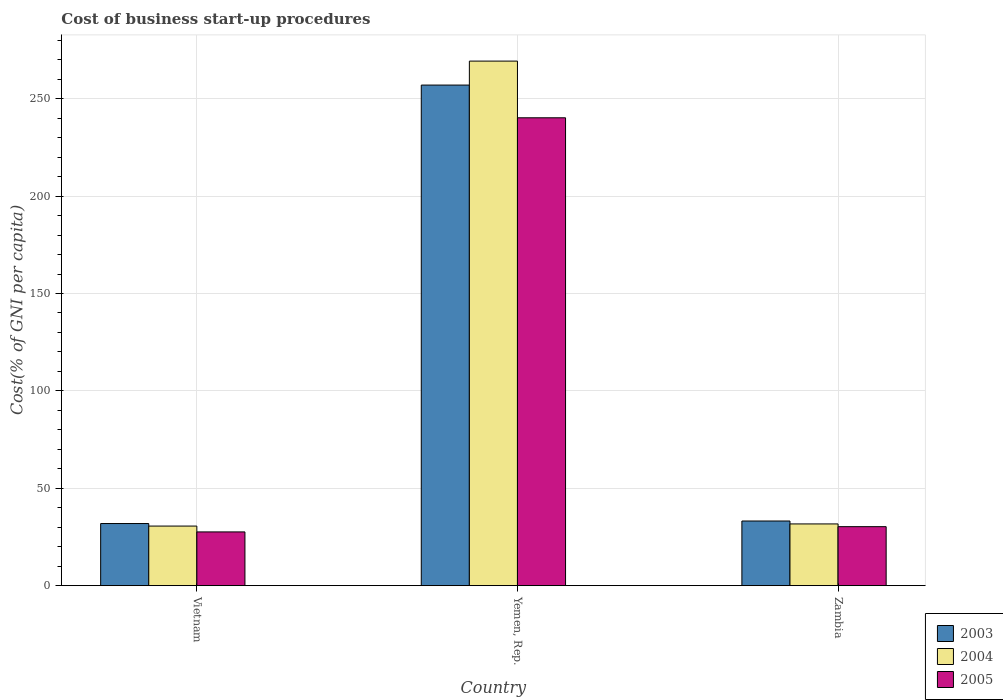How many groups of bars are there?
Give a very brief answer. 3. How many bars are there on the 2nd tick from the right?
Make the answer very short. 3. What is the label of the 2nd group of bars from the left?
Your answer should be compact. Yemen, Rep. What is the cost of business start-up procedures in 2005 in Vietnam?
Provide a short and direct response. 27.6. Across all countries, what is the maximum cost of business start-up procedures in 2005?
Your answer should be very brief. 240.2. Across all countries, what is the minimum cost of business start-up procedures in 2003?
Ensure brevity in your answer.  31.9. In which country was the cost of business start-up procedures in 2003 maximum?
Your response must be concise. Yemen, Rep. In which country was the cost of business start-up procedures in 2005 minimum?
Provide a short and direct response. Vietnam. What is the total cost of business start-up procedures in 2005 in the graph?
Offer a very short reply. 298.1. What is the difference between the cost of business start-up procedures in 2005 in Vietnam and that in Yemen, Rep.?
Give a very brief answer. -212.6. What is the difference between the cost of business start-up procedures in 2003 in Yemen, Rep. and the cost of business start-up procedures in 2004 in Zambia?
Provide a succinct answer. 225.3. What is the average cost of business start-up procedures in 2003 per country?
Make the answer very short. 107.37. What is the difference between the cost of business start-up procedures of/in 2003 and cost of business start-up procedures of/in 2005 in Yemen, Rep.?
Provide a short and direct response. 16.8. What is the ratio of the cost of business start-up procedures in 2003 in Vietnam to that in Zambia?
Your answer should be very brief. 0.96. Is the difference between the cost of business start-up procedures in 2003 in Vietnam and Zambia greater than the difference between the cost of business start-up procedures in 2005 in Vietnam and Zambia?
Provide a succinct answer. Yes. What is the difference between the highest and the second highest cost of business start-up procedures in 2003?
Your response must be concise. 225.1. What is the difference between the highest and the lowest cost of business start-up procedures in 2005?
Give a very brief answer. 212.6. Is the sum of the cost of business start-up procedures in 2004 in Vietnam and Zambia greater than the maximum cost of business start-up procedures in 2005 across all countries?
Give a very brief answer. No. What does the 2nd bar from the left in Yemen, Rep. represents?
Make the answer very short. 2004. Is it the case that in every country, the sum of the cost of business start-up procedures in 2003 and cost of business start-up procedures in 2004 is greater than the cost of business start-up procedures in 2005?
Provide a succinct answer. Yes. How many countries are there in the graph?
Your answer should be very brief. 3. Does the graph contain any zero values?
Provide a short and direct response. No. Does the graph contain grids?
Make the answer very short. Yes. Where does the legend appear in the graph?
Offer a very short reply. Bottom right. What is the title of the graph?
Provide a short and direct response. Cost of business start-up procedures. What is the label or title of the X-axis?
Offer a terse response. Country. What is the label or title of the Y-axis?
Keep it short and to the point. Cost(% of GNI per capita). What is the Cost(% of GNI per capita) of 2003 in Vietnam?
Provide a succinct answer. 31.9. What is the Cost(% of GNI per capita) of 2004 in Vietnam?
Ensure brevity in your answer.  30.6. What is the Cost(% of GNI per capita) in 2005 in Vietnam?
Your answer should be compact. 27.6. What is the Cost(% of GNI per capita) in 2003 in Yemen, Rep.?
Provide a succinct answer. 257. What is the Cost(% of GNI per capita) of 2004 in Yemen, Rep.?
Offer a very short reply. 269.3. What is the Cost(% of GNI per capita) of 2005 in Yemen, Rep.?
Provide a short and direct response. 240.2. What is the Cost(% of GNI per capita) of 2003 in Zambia?
Ensure brevity in your answer.  33.2. What is the Cost(% of GNI per capita) in 2004 in Zambia?
Make the answer very short. 31.7. What is the Cost(% of GNI per capita) of 2005 in Zambia?
Ensure brevity in your answer.  30.3. Across all countries, what is the maximum Cost(% of GNI per capita) of 2003?
Your answer should be compact. 257. Across all countries, what is the maximum Cost(% of GNI per capita) in 2004?
Offer a terse response. 269.3. Across all countries, what is the maximum Cost(% of GNI per capita) in 2005?
Provide a succinct answer. 240.2. Across all countries, what is the minimum Cost(% of GNI per capita) in 2003?
Your response must be concise. 31.9. Across all countries, what is the minimum Cost(% of GNI per capita) of 2004?
Offer a terse response. 30.6. Across all countries, what is the minimum Cost(% of GNI per capita) in 2005?
Your response must be concise. 27.6. What is the total Cost(% of GNI per capita) of 2003 in the graph?
Keep it short and to the point. 322.1. What is the total Cost(% of GNI per capita) in 2004 in the graph?
Ensure brevity in your answer.  331.6. What is the total Cost(% of GNI per capita) of 2005 in the graph?
Your answer should be compact. 298.1. What is the difference between the Cost(% of GNI per capita) in 2003 in Vietnam and that in Yemen, Rep.?
Keep it short and to the point. -225.1. What is the difference between the Cost(% of GNI per capita) in 2004 in Vietnam and that in Yemen, Rep.?
Ensure brevity in your answer.  -238.7. What is the difference between the Cost(% of GNI per capita) in 2005 in Vietnam and that in Yemen, Rep.?
Give a very brief answer. -212.6. What is the difference between the Cost(% of GNI per capita) in 2003 in Vietnam and that in Zambia?
Keep it short and to the point. -1.3. What is the difference between the Cost(% of GNI per capita) in 2003 in Yemen, Rep. and that in Zambia?
Offer a very short reply. 223.8. What is the difference between the Cost(% of GNI per capita) in 2004 in Yemen, Rep. and that in Zambia?
Your response must be concise. 237.6. What is the difference between the Cost(% of GNI per capita) of 2005 in Yemen, Rep. and that in Zambia?
Ensure brevity in your answer.  209.9. What is the difference between the Cost(% of GNI per capita) in 2003 in Vietnam and the Cost(% of GNI per capita) in 2004 in Yemen, Rep.?
Give a very brief answer. -237.4. What is the difference between the Cost(% of GNI per capita) in 2003 in Vietnam and the Cost(% of GNI per capita) in 2005 in Yemen, Rep.?
Ensure brevity in your answer.  -208.3. What is the difference between the Cost(% of GNI per capita) of 2004 in Vietnam and the Cost(% of GNI per capita) of 2005 in Yemen, Rep.?
Keep it short and to the point. -209.6. What is the difference between the Cost(% of GNI per capita) in 2003 in Vietnam and the Cost(% of GNI per capita) in 2005 in Zambia?
Offer a very short reply. 1.6. What is the difference between the Cost(% of GNI per capita) in 2004 in Vietnam and the Cost(% of GNI per capita) in 2005 in Zambia?
Your response must be concise. 0.3. What is the difference between the Cost(% of GNI per capita) of 2003 in Yemen, Rep. and the Cost(% of GNI per capita) of 2004 in Zambia?
Ensure brevity in your answer.  225.3. What is the difference between the Cost(% of GNI per capita) of 2003 in Yemen, Rep. and the Cost(% of GNI per capita) of 2005 in Zambia?
Ensure brevity in your answer.  226.7. What is the difference between the Cost(% of GNI per capita) of 2004 in Yemen, Rep. and the Cost(% of GNI per capita) of 2005 in Zambia?
Keep it short and to the point. 239. What is the average Cost(% of GNI per capita) in 2003 per country?
Provide a short and direct response. 107.37. What is the average Cost(% of GNI per capita) of 2004 per country?
Offer a terse response. 110.53. What is the average Cost(% of GNI per capita) in 2005 per country?
Your response must be concise. 99.37. What is the difference between the Cost(% of GNI per capita) of 2003 and Cost(% of GNI per capita) of 2005 in Yemen, Rep.?
Offer a terse response. 16.8. What is the difference between the Cost(% of GNI per capita) in 2004 and Cost(% of GNI per capita) in 2005 in Yemen, Rep.?
Provide a short and direct response. 29.1. What is the difference between the Cost(% of GNI per capita) of 2003 and Cost(% of GNI per capita) of 2005 in Zambia?
Your response must be concise. 2.9. What is the difference between the Cost(% of GNI per capita) in 2004 and Cost(% of GNI per capita) in 2005 in Zambia?
Your answer should be compact. 1.4. What is the ratio of the Cost(% of GNI per capita) of 2003 in Vietnam to that in Yemen, Rep.?
Your response must be concise. 0.12. What is the ratio of the Cost(% of GNI per capita) of 2004 in Vietnam to that in Yemen, Rep.?
Your response must be concise. 0.11. What is the ratio of the Cost(% of GNI per capita) in 2005 in Vietnam to that in Yemen, Rep.?
Your response must be concise. 0.11. What is the ratio of the Cost(% of GNI per capita) of 2003 in Vietnam to that in Zambia?
Make the answer very short. 0.96. What is the ratio of the Cost(% of GNI per capita) in 2004 in Vietnam to that in Zambia?
Keep it short and to the point. 0.97. What is the ratio of the Cost(% of GNI per capita) in 2005 in Vietnam to that in Zambia?
Keep it short and to the point. 0.91. What is the ratio of the Cost(% of GNI per capita) of 2003 in Yemen, Rep. to that in Zambia?
Keep it short and to the point. 7.74. What is the ratio of the Cost(% of GNI per capita) of 2004 in Yemen, Rep. to that in Zambia?
Offer a terse response. 8.5. What is the ratio of the Cost(% of GNI per capita) of 2005 in Yemen, Rep. to that in Zambia?
Provide a succinct answer. 7.93. What is the difference between the highest and the second highest Cost(% of GNI per capita) of 2003?
Make the answer very short. 223.8. What is the difference between the highest and the second highest Cost(% of GNI per capita) of 2004?
Make the answer very short. 237.6. What is the difference between the highest and the second highest Cost(% of GNI per capita) of 2005?
Your answer should be very brief. 209.9. What is the difference between the highest and the lowest Cost(% of GNI per capita) of 2003?
Give a very brief answer. 225.1. What is the difference between the highest and the lowest Cost(% of GNI per capita) in 2004?
Ensure brevity in your answer.  238.7. What is the difference between the highest and the lowest Cost(% of GNI per capita) of 2005?
Offer a very short reply. 212.6. 